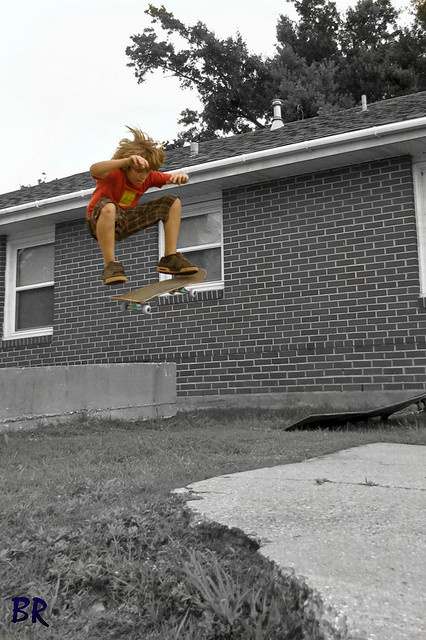Describe the objects in this image and their specific colors. I can see people in white, maroon, black, and olive tones and skateboard in white, gray, olive, and darkgray tones in this image. 